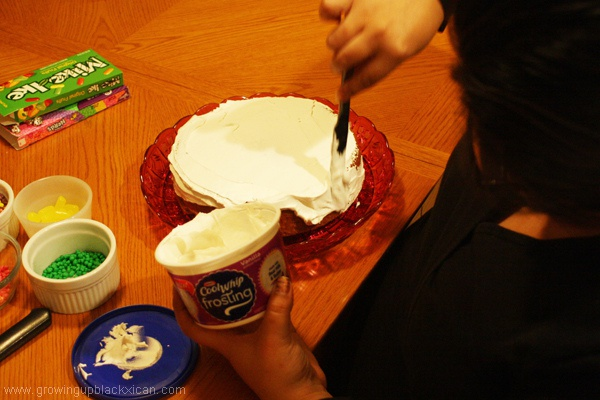Describe the objects in this image and their specific colors. I can see dining table in maroon, red, brown, and khaki tones, people in maroon, black, and brown tones, bowl in maroon, khaki, and lightyellow tones, cake in maroon, khaki, lightyellow, and tan tones, and bowl in maroon, olive, tan, and khaki tones in this image. 